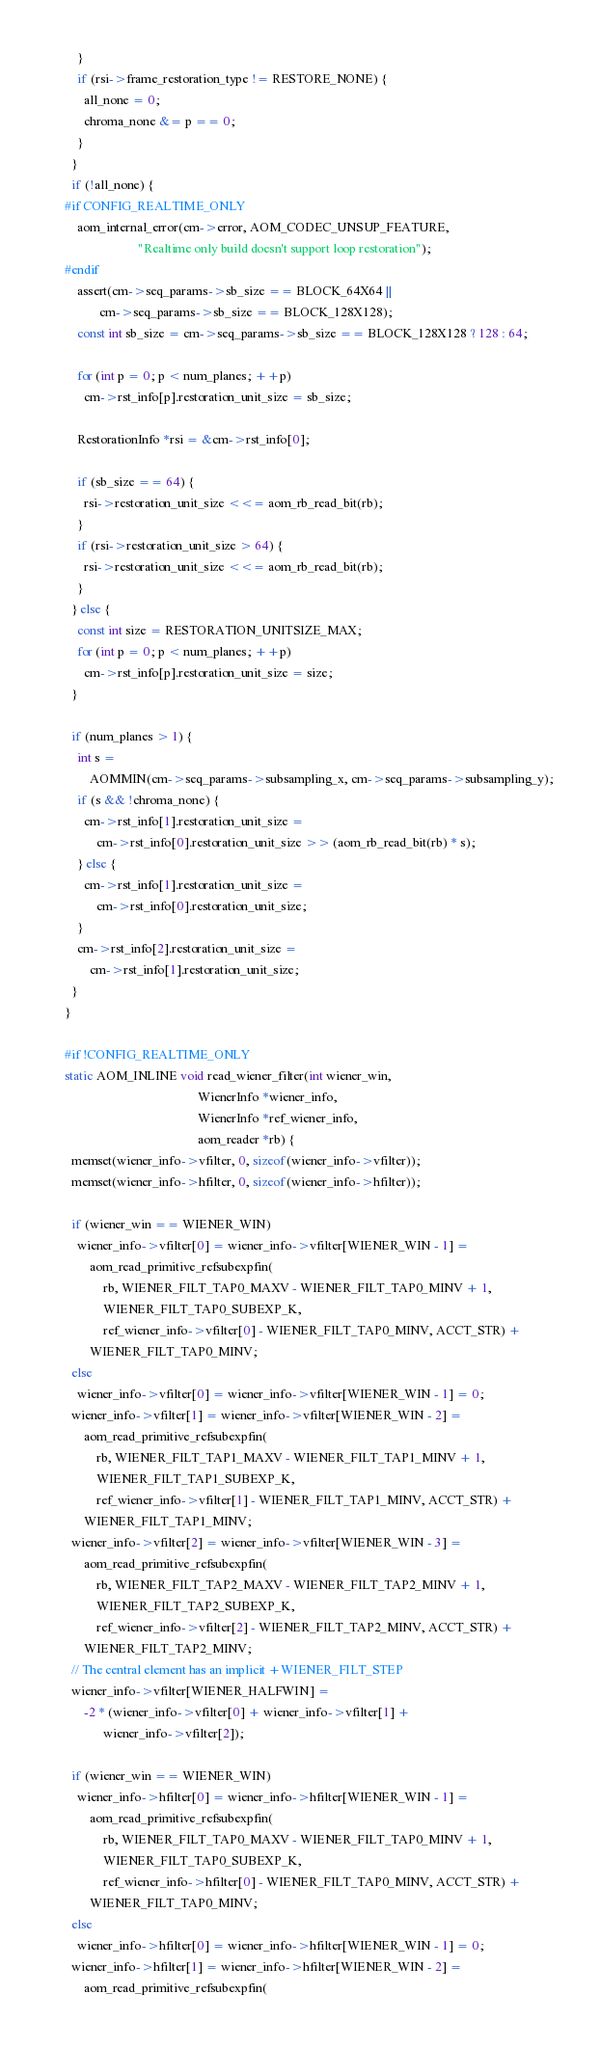<code> <loc_0><loc_0><loc_500><loc_500><_C_>    }
    if (rsi->frame_restoration_type != RESTORE_NONE) {
      all_none = 0;
      chroma_none &= p == 0;
    }
  }
  if (!all_none) {
#if CONFIG_REALTIME_ONLY
    aom_internal_error(cm->error, AOM_CODEC_UNSUP_FEATURE,
                       "Realtime only build doesn't support loop restoration");
#endif
    assert(cm->seq_params->sb_size == BLOCK_64X64 ||
           cm->seq_params->sb_size == BLOCK_128X128);
    const int sb_size = cm->seq_params->sb_size == BLOCK_128X128 ? 128 : 64;

    for (int p = 0; p < num_planes; ++p)
      cm->rst_info[p].restoration_unit_size = sb_size;

    RestorationInfo *rsi = &cm->rst_info[0];

    if (sb_size == 64) {
      rsi->restoration_unit_size <<= aom_rb_read_bit(rb);
    }
    if (rsi->restoration_unit_size > 64) {
      rsi->restoration_unit_size <<= aom_rb_read_bit(rb);
    }
  } else {
    const int size = RESTORATION_UNITSIZE_MAX;
    for (int p = 0; p < num_planes; ++p)
      cm->rst_info[p].restoration_unit_size = size;
  }

  if (num_planes > 1) {
    int s =
        AOMMIN(cm->seq_params->subsampling_x, cm->seq_params->subsampling_y);
    if (s && !chroma_none) {
      cm->rst_info[1].restoration_unit_size =
          cm->rst_info[0].restoration_unit_size >> (aom_rb_read_bit(rb) * s);
    } else {
      cm->rst_info[1].restoration_unit_size =
          cm->rst_info[0].restoration_unit_size;
    }
    cm->rst_info[2].restoration_unit_size =
        cm->rst_info[1].restoration_unit_size;
  }
}

#if !CONFIG_REALTIME_ONLY
static AOM_INLINE void read_wiener_filter(int wiener_win,
                                          WienerInfo *wiener_info,
                                          WienerInfo *ref_wiener_info,
                                          aom_reader *rb) {
  memset(wiener_info->vfilter, 0, sizeof(wiener_info->vfilter));
  memset(wiener_info->hfilter, 0, sizeof(wiener_info->hfilter));

  if (wiener_win == WIENER_WIN)
    wiener_info->vfilter[0] = wiener_info->vfilter[WIENER_WIN - 1] =
        aom_read_primitive_refsubexpfin(
            rb, WIENER_FILT_TAP0_MAXV - WIENER_FILT_TAP0_MINV + 1,
            WIENER_FILT_TAP0_SUBEXP_K,
            ref_wiener_info->vfilter[0] - WIENER_FILT_TAP0_MINV, ACCT_STR) +
        WIENER_FILT_TAP0_MINV;
  else
    wiener_info->vfilter[0] = wiener_info->vfilter[WIENER_WIN - 1] = 0;
  wiener_info->vfilter[1] = wiener_info->vfilter[WIENER_WIN - 2] =
      aom_read_primitive_refsubexpfin(
          rb, WIENER_FILT_TAP1_MAXV - WIENER_FILT_TAP1_MINV + 1,
          WIENER_FILT_TAP1_SUBEXP_K,
          ref_wiener_info->vfilter[1] - WIENER_FILT_TAP1_MINV, ACCT_STR) +
      WIENER_FILT_TAP1_MINV;
  wiener_info->vfilter[2] = wiener_info->vfilter[WIENER_WIN - 3] =
      aom_read_primitive_refsubexpfin(
          rb, WIENER_FILT_TAP2_MAXV - WIENER_FILT_TAP2_MINV + 1,
          WIENER_FILT_TAP2_SUBEXP_K,
          ref_wiener_info->vfilter[2] - WIENER_FILT_TAP2_MINV, ACCT_STR) +
      WIENER_FILT_TAP2_MINV;
  // The central element has an implicit +WIENER_FILT_STEP
  wiener_info->vfilter[WIENER_HALFWIN] =
      -2 * (wiener_info->vfilter[0] + wiener_info->vfilter[1] +
            wiener_info->vfilter[2]);

  if (wiener_win == WIENER_WIN)
    wiener_info->hfilter[0] = wiener_info->hfilter[WIENER_WIN - 1] =
        aom_read_primitive_refsubexpfin(
            rb, WIENER_FILT_TAP0_MAXV - WIENER_FILT_TAP0_MINV + 1,
            WIENER_FILT_TAP0_SUBEXP_K,
            ref_wiener_info->hfilter[0] - WIENER_FILT_TAP0_MINV, ACCT_STR) +
        WIENER_FILT_TAP0_MINV;
  else
    wiener_info->hfilter[0] = wiener_info->hfilter[WIENER_WIN - 1] = 0;
  wiener_info->hfilter[1] = wiener_info->hfilter[WIENER_WIN - 2] =
      aom_read_primitive_refsubexpfin(</code> 